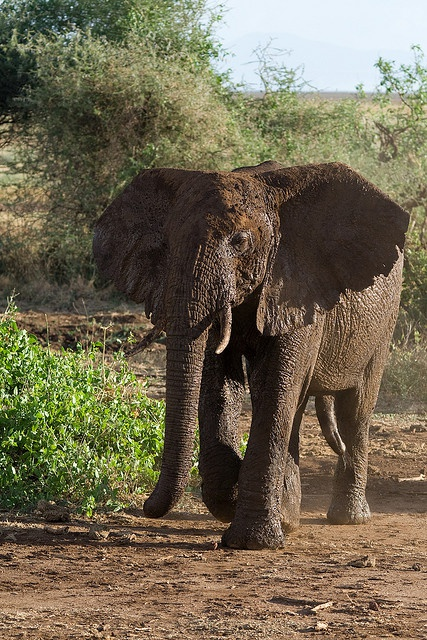Describe the objects in this image and their specific colors. I can see a elephant in lightgray, black, gray, and maroon tones in this image. 